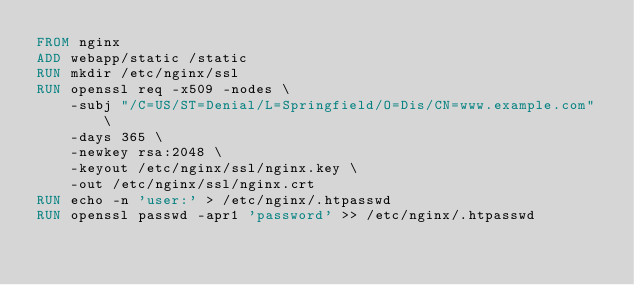Convert code to text. <code><loc_0><loc_0><loc_500><loc_500><_Dockerfile_>FROM nginx
ADD webapp/static /static
RUN mkdir /etc/nginx/ssl
RUN openssl req -x509 -nodes \
    -subj "/C=US/ST=Denial/L=Springfield/O=Dis/CN=www.example.com" \
    -days 365 \
    -newkey rsa:2048 \
    -keyout /etc/nginx/ssl/nginx.key \
    -out /etc/nginx/ssl/nginx.crt
RUN echo -n 'user:' > /etc/nginx/.htpasswd
RUN openssl passwd -apr1 'password' >> /etc/nginx/.htpasswd
</code> 